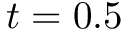<formula> <loc_0><loc_0><loc_500><loc_500>t = 0 . 5</formula> 